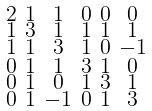Convert formula to latex. <formula><loc_0><loc_0><loc_500><loc_500>\begin{smallmatrix} 2 & 1 & 1 & 0 & 0 & 0 \\ 1 & 3 & 1 & 1 & 1 & 1 \\ 1 & 1 & 3 & 1 & 0 & - 1 \\ 0 & 1 & 1 & 3 & 1 & 0 \\ 0 & 1 & 0 & 1 & 3 & 1 \\ 0 & 1 & - 1 & 0 & 1 & 3 \end{smallmatrix}</formula> 